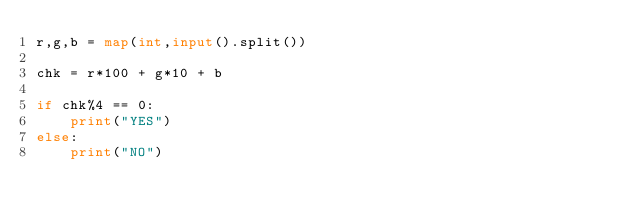Convert code to text. <code><loc_0><loc_0><loc_500><loc_500><_Python_>r,g,b = map(int,input().split())

chk = r*100 + g*10 + b

if chk%4 == 0:
    print("YES")
else:
    print("NO")</code> 